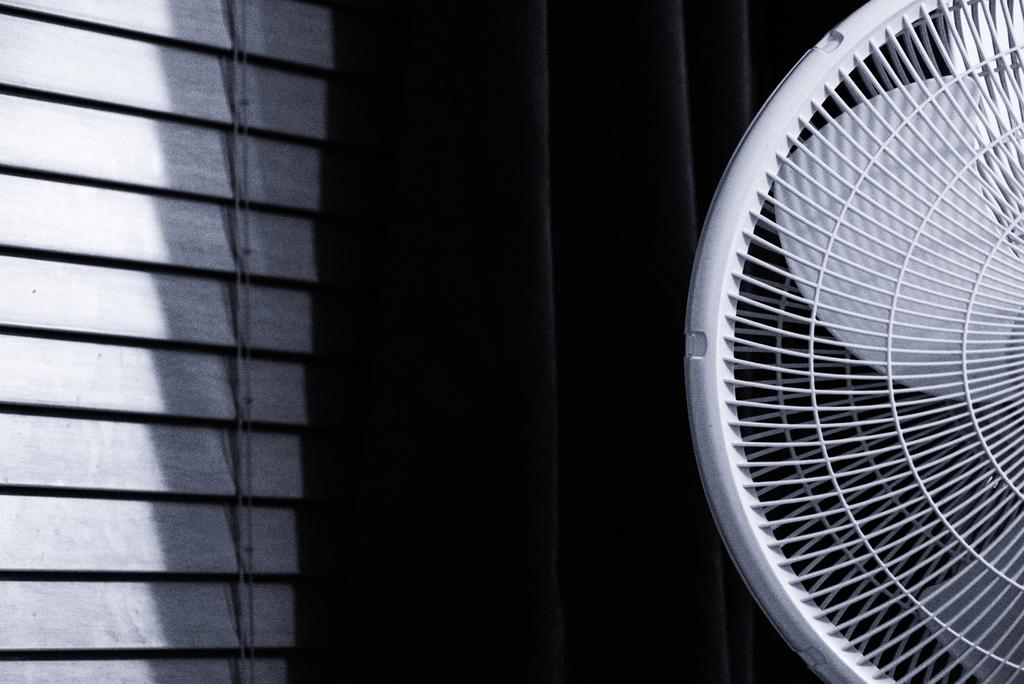What type of appliance is visible in the image? There is a table fan in the image. What type of window covering is present in the image? There is a curtain and a window blind on the left side of the image. What is the tendency of the nut to change the texture of the table fan in the image? There is no nut present in the image, and therefore no such interaction can be observed. 